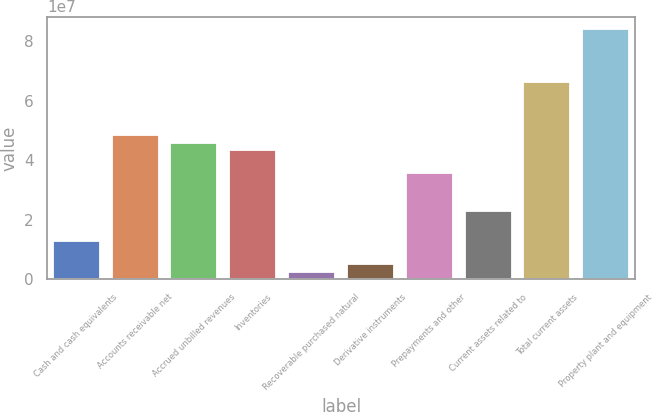Convert chart. <chart><loc_0><loc_0><loc_500><loc_500><bar_chart><fcel>Cash and cash equivalents<fcel>Accounts receivable net<fcel>Accrued unbilled revenues<fcel>Inventories<fcel>Recoverable purchased natural<fcel>Derivative instruments<fcel>Prepayments and other<fcel>Current assets related to<fcel>Total current assets<fcel>Property plant and equipment<nl><fcel>1.27588e+07<fcel>4.84018e+07<fcel>4.58559e+07<fcel>4.331e+07<fcel>2.57501e+06<fcel>5.12095e+06<fcel>3.56722e+07<fcel>2.29425e+07<fcel>6.62234e+07<fcel>8.40449e+07<nl></chart> 